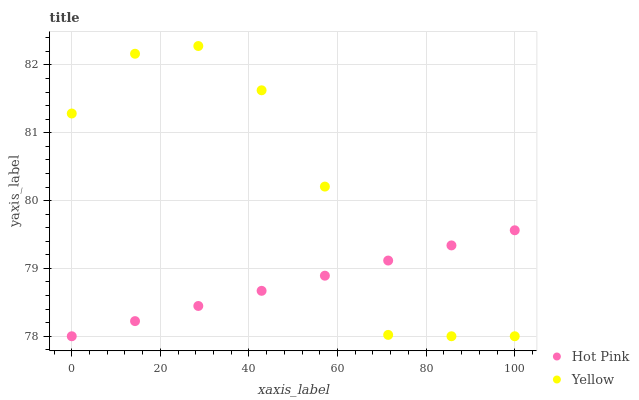Does Hot Pink have the minimum area under the curve?
Answer yes or no. Yes. Does Yellow have the maximum area under the curve?
Answer yes or no. Yes. Does Yellow have the minimum area under the curve?
Answer yes or no. No. Is Hot Pink the smoothest?
Answer yes or no. Yes. Is Yellow the roughest?
Answer yes or no. Yes. Is Yellow the smoothest?
Answer yes or no. No. Does Hot Pink have the lowest value?
Answer yes or no. Yes. Does Yellow have the highest value?
Answer yes or no. Yes. Does Hot Pink intersect Yellow?
Answer yes or no. Yes. Is Hot Pink less than Yellow?
Answer yes or no. No. Is Hot Pink greater than Yellow?
Answer yes or no. No. 